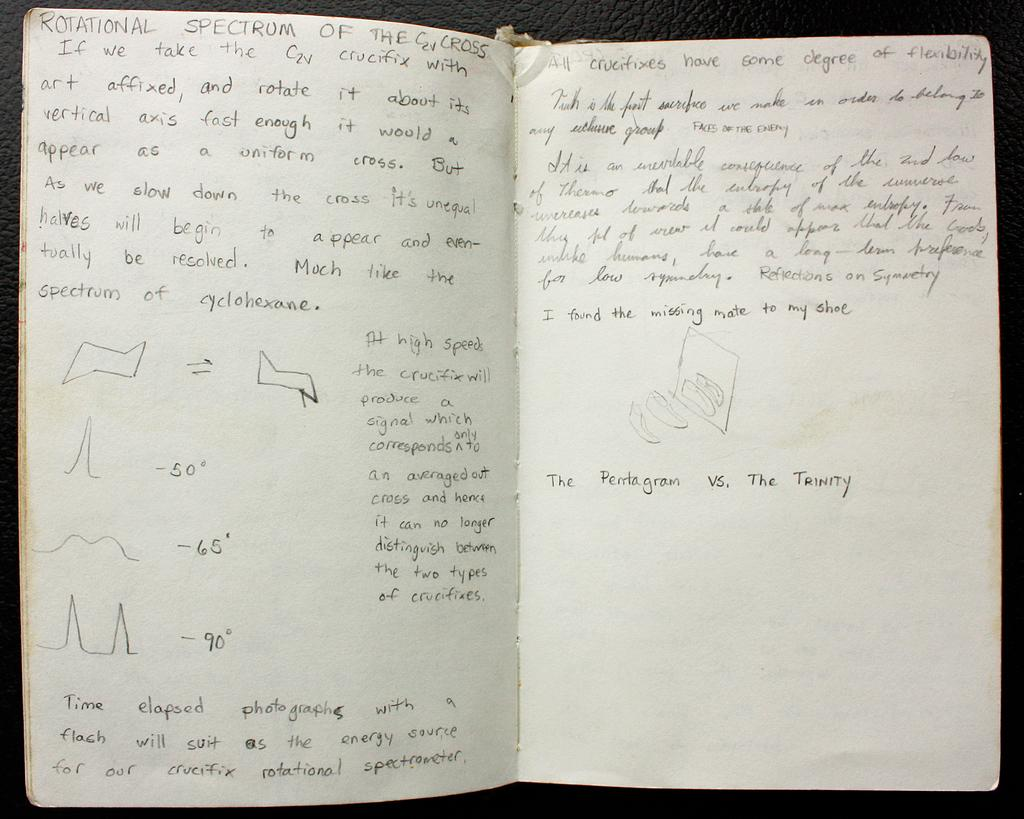<image>
Relay a brief, clear account of the picture shown. Handwritten notes in a notebook start with the title "Rotational Spectrum of the C2V Cross". 